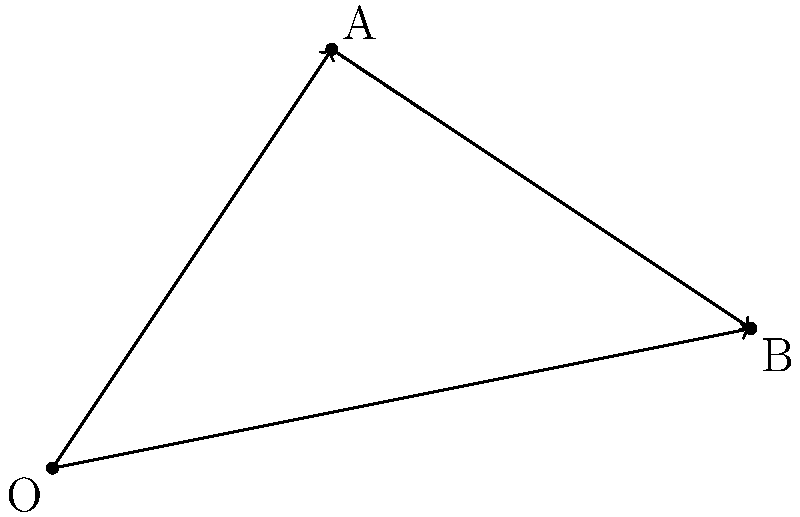In a robotic vision system, two objects A and B are detected relative to the camera's origin O. Given that object A's position vector $\vec{r}_A = 2\hat{i} + 3\hat{j}$ and object B's position vector $\vec{r}_B = 5\hat{i} + \hat{j}$, calculate the relative position vector $\vec{r}_{BA}$ from object A to object B. To find the relative position vector $\vec{r}_{BA}$ from object A to object B, we need to follow these steps:

1. Understand that the relative position vector $\vec{r}_{BA}$ represents the displacement from A to B.

2. Recall that vector subtraction can be used to find the displacement between two points:
   $\vec{r}_{BA} = \vec{r}_B - \vec{r}_A$

3. Substitute the given position vectors:
   $\vec{r}_{BA} = (5\hat{i} + \hat{j}) - (2\hat{i} + 3\hat{j})$

4. Perform vector subtraction by subtracting corresponding components:
   $\vec{r}_{BA} = (5\hat{i} - 2\hat{i}) + (\hat{j} - 3\hat{j})$

5. Simplify:
   $\vec{r}_{BA} = 3\hat{i} - 2\hat{j}$

Therefore, the relative position vector from object A to object B is $3\hat{i} - 2\hat{j}$.
Answer: $3\hat{i} - 2\hat{j}$ 